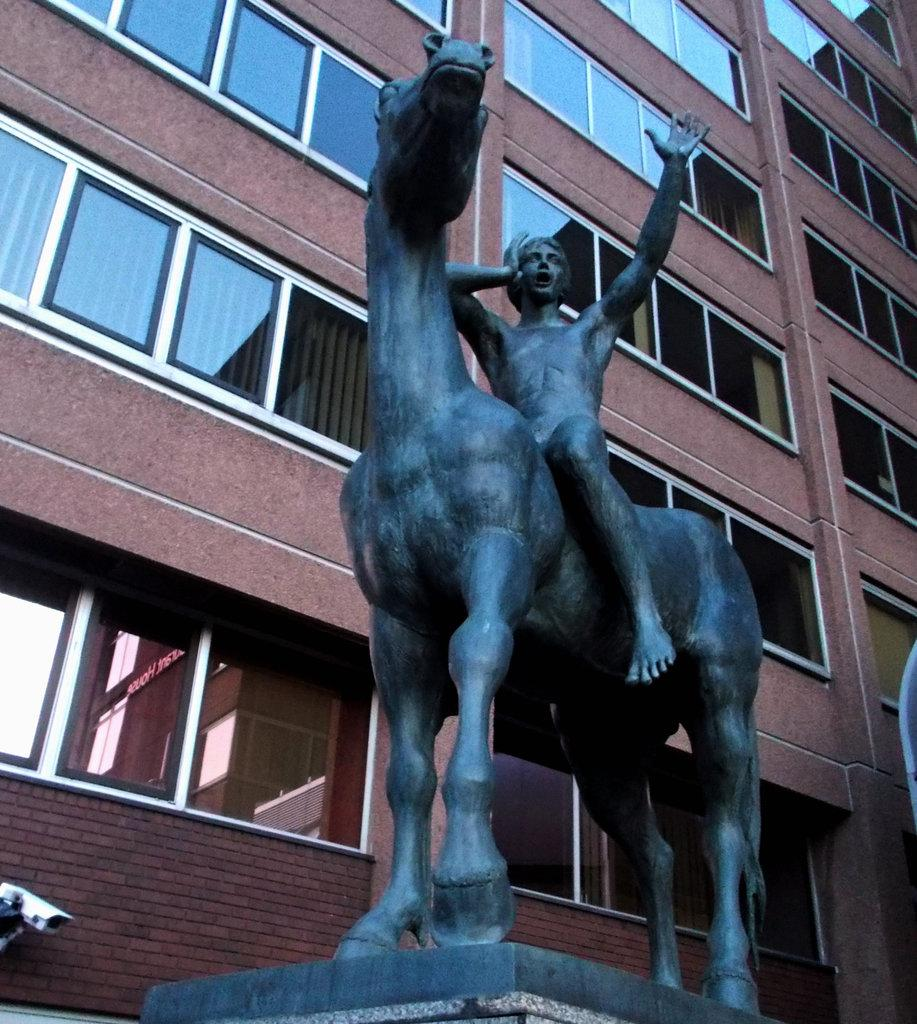What type of object is the main subject of the image? There is a statue of an animal in the image. What is happening with the statue in the image? A person is sitting on the statue. What can be seen in the background of the image? There are buildings with windows in the background of the image. What type of stitch is being used to repair the statue in the image? There is no indication in the image that the statue is being repaired, nor is there any mention of a stitch. 